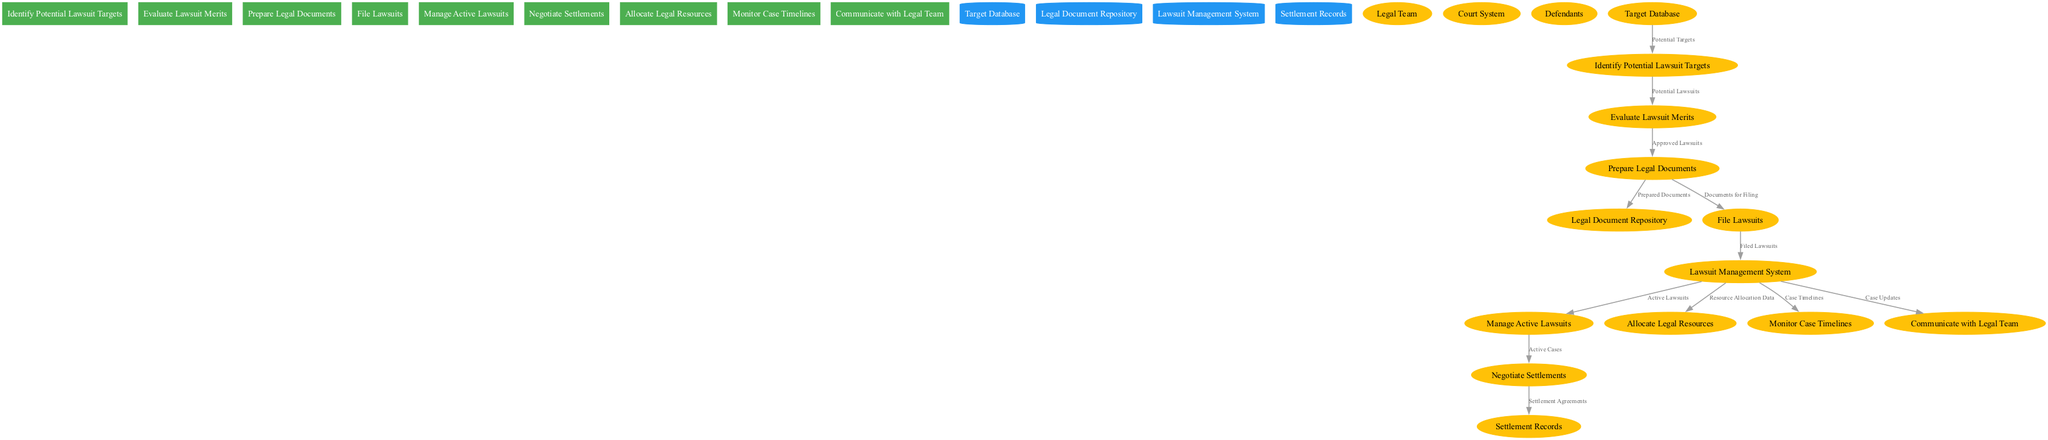What is the first process in the diagram? The first process listed in the diagram is "Identify Potential Lawsuit Targets," which is the starting point of the flow.
Answer: Identify Potential Lawsuit Targets How many data stores are present in the diagram? There are four data stores listed, which are "Target Database," "Legal Document Repository," "Lawsuit Management System," and "Settlement Records."
Answer: 4 Which process follows "Prepare Legal Documents"? The process that follows "Prepare Legal Documents" is "File Lawsuits," which indicates the next step after document preparation.
Answer: File Lawsuits What is the source for the flow labeled "Documents for Filing"? The source for the flow labeled "Documents for Filing" is "Prepare Legal Documents," which indicates that documents being filed come directly from the previous stage of preparation.
Answer: Prepare Legal Documents Which external entity is involved in communication according to the diagram? The external entity involved in communication is the "Legal Team," which indicates that updates and information flow to this group.
Answer: Legal Team Which process does the "Settlement Agreements" flow into? The "Settlement Agreements" flow goes into "Settlement Records," which shows where the agreements are documented after negotiations.
Answer: Settlement Records What is the purpose of the "Monitor Case Timelines" process? The purpose of "Monitor Case Timelines" is to keep track of the progress of lawsuits over time, which is crucial for managing timelines effectively.
Answer: Manage timelines How many processes are connected to the "Lawsuit Management System"? There are four processes connected to the "Lawsuit Management System": "Manage Active Lawsuits," "Allocate Legal Resources," "Monitor Case Timelines," and "Communicate with Legal Team."
Answer: 4 Which data flow connects "Negotiate Settlements" to another entity? The data flow that connects "Negotiate Settlements" to another entity is labeled "Settlement Agreements," indicating the output after negotiations to the records.
Answer: Settlement Agreements 